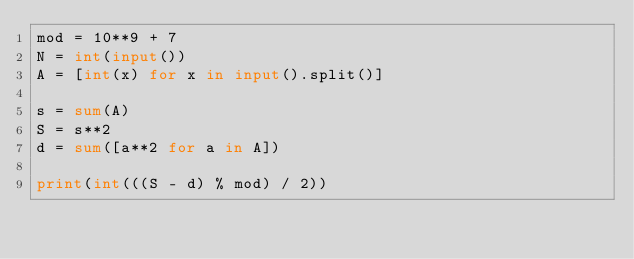<code> <loc_0><loc_0><loc_500><loc_500><_Python_>mod = 10**9 + 7
N = int(input())
A = [int(x) for x in input().split()]

s = sum(A)
S = s**2
d = sum([a**2 for a in A])

print(int(((S - d) % mod) / 2))
</code> 